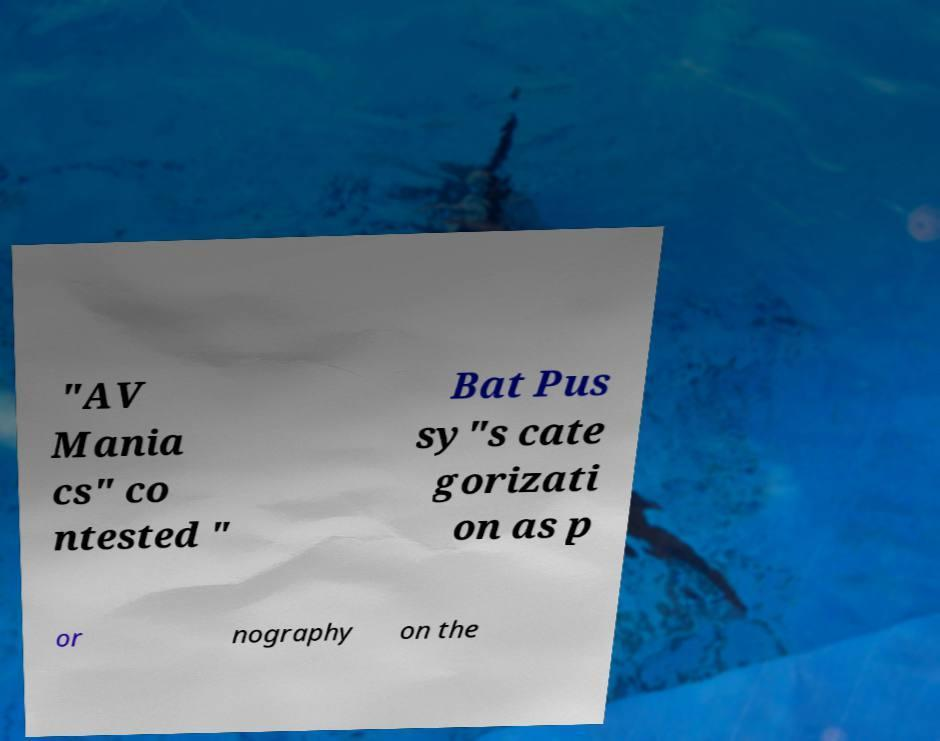For documentation purposes, I need the text within this image transcribed. Could you provide that? "AV Mania cs" co ntested " Bat Pus sy"s cate gorizati on as p or nography on the 